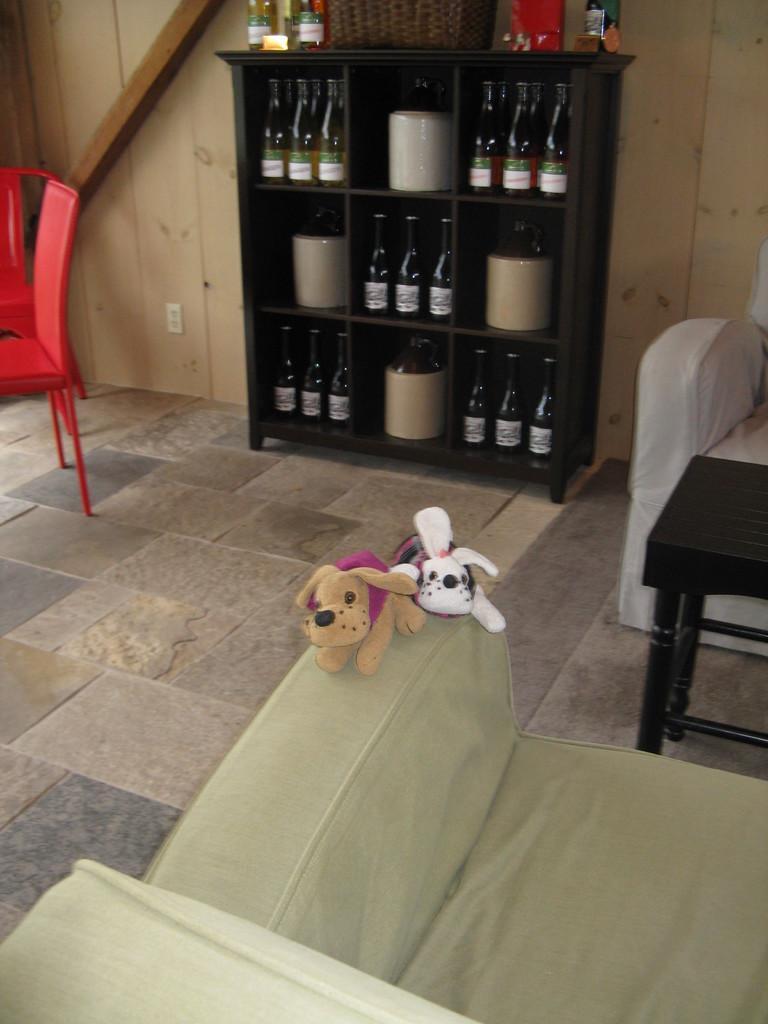Can you describe this image briefly? In the image there are teddy bears on sofa and on to the wall there are shelves with wine bottles in it and there are chairs on right and left side of the room. 